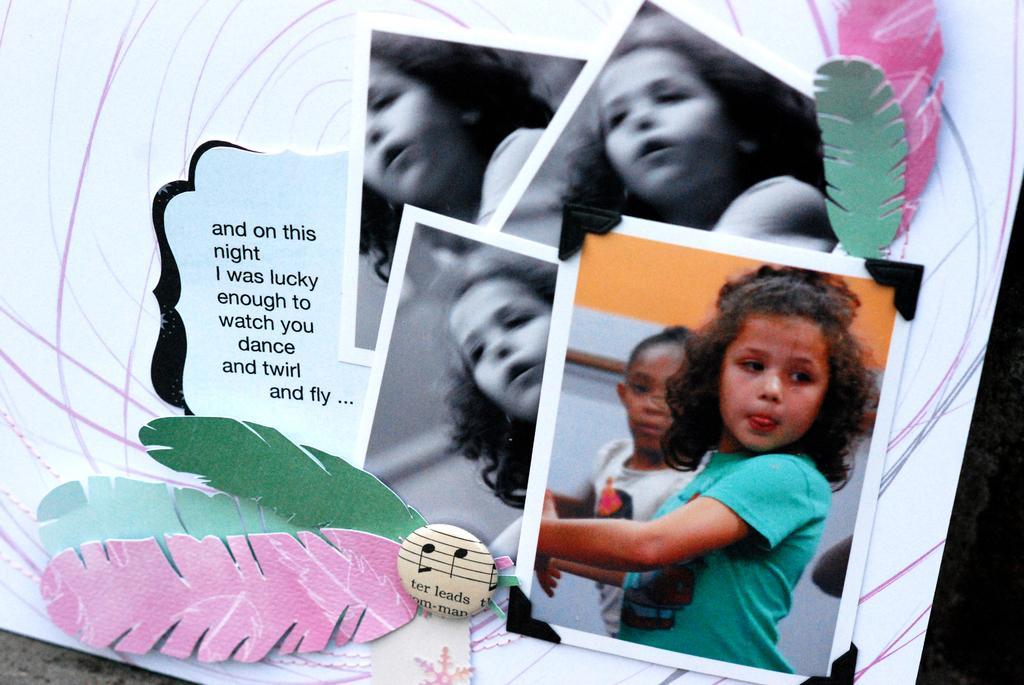Describe this image in one or two sentences. In this picture we can see a board with photos of a girl, feathers and some text on it and in the background it is dark. 